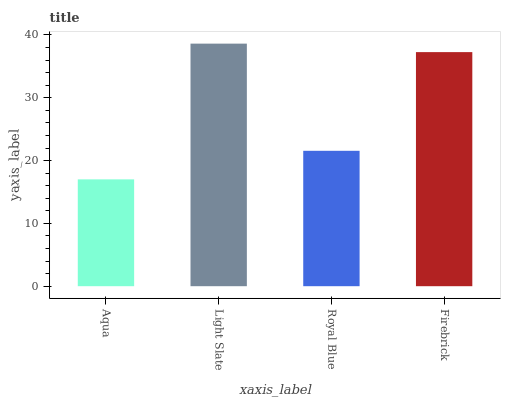Is Aqua the minimum?
Answer yes or no. Yes. Is Light Slate the maximum?
Answer yes or no. Yes. Is Royal Blue the minimum?
Answer yes or no. No. Is Royal Blue the maximum?
Answer yes or no. No. Is Light Slate greater than Royal Blue?
Answer yes or no. Yes. Is Royal Blue less than Light Slate?
Answer yes or no. Yes. Is Royal Blue greater than Light Slate?
Answer yes or no. No. Is Light Slate less than Royal Blue?
Answer yes or no. No. Is Firebrick the high median?
Answer yes or no. Yes. Is Royal Blue the low median?
Answer yes or no. Yes. Is Light Slate the high median?
Answer yes or no. No. Is Light Slate the low median?
Answer yes or no. No. 